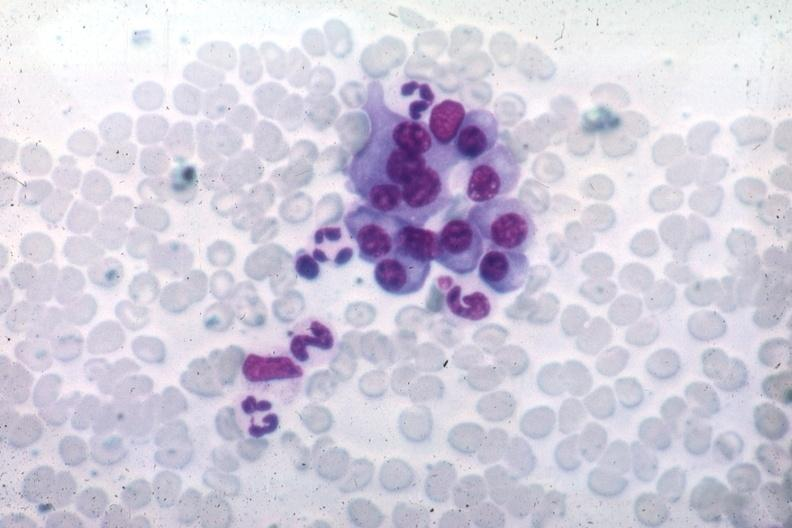s lymphoma present?
Answer the question using a single word or phrase. No 